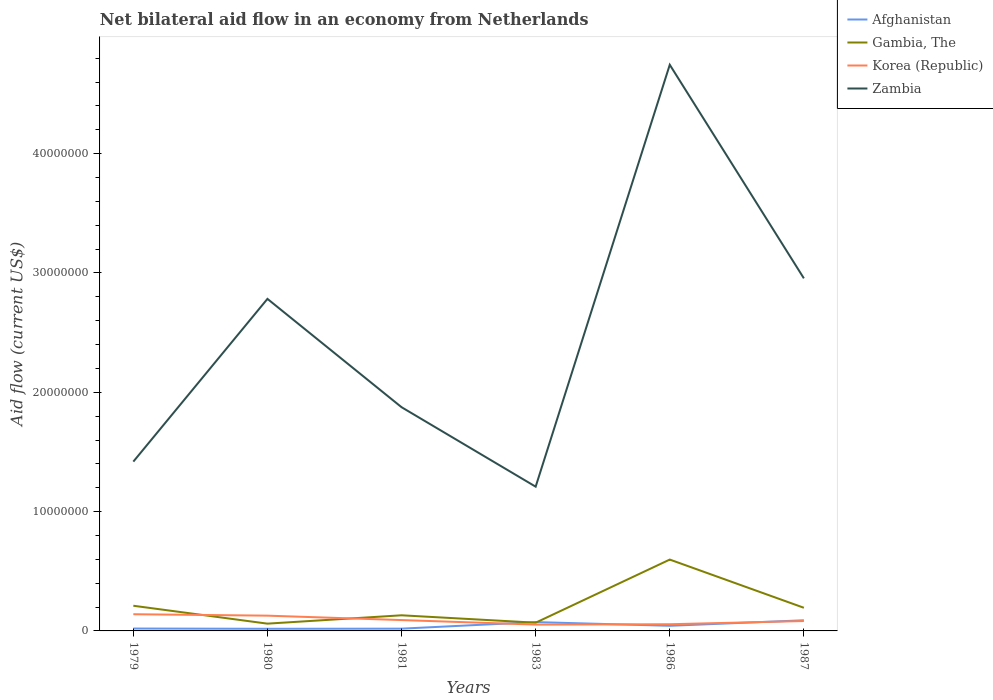Does the line corresponding to Korea (Republic) intersect with the line corresponding to Zambia?
Offer a terse response. No. Across all years, what is the maximum net bilateral aid flow in Korea (Republic)?
Provide a succinct answer. 5.30e+05. What is the total net bilateral aid flow in Gambia, The in the graph?
Make the answer very short. -4.67e+06. What is the difference between the highest and the second highest net bilateral aid flow in Gambia, The?
Your answer should be very brief. 5.37e+06. What is the difference between the highest and the lowest net bilateral aid flow in Gambia, The?
Provide a succinct answer. 2. What is the difference between two consecutive major ticks on the Y-axis?
Offer a very short reply. 1.00e+07. Are the values on the major ticks of Y-axis written in scientific E-notation?
Provide a succinct answer. No. Does the graph contain any zero values?
Give a very brief answer. No. Does the graph contain grids?
Offer a terse response. No. What is the title of the graph?
Make the answer very short. Net bilateral aid flow in an economy from Netherlands. What is the label or title of the Y-axis?
Keep it short and to the point. Aid flow (current US$). What is the Aid flow (current US$) in Afghanistan in 1979?
Provide a succinct answer. 2.00e+05. What is the Aid flow (current US$) in Gambia, The in 1979?
Your answer should be compact. 2.11e+06. What is the Aid flow (current US$) of Korea (Republic) in 1979?
Keep it short and to the point. 1.40e+06. What is the Aid flow (current US$) in Zambia in 1979?
Your answer should be very brief. 1.42e+07. What is the Aid flow (current US$) in Gambia, The in 1980?
Provide a short and direct response. 6.10e+05. What is the Aid flow (current US$) of Korea (Republic) in 1980?
Provide a succinct answer. 1.28e+06. What is the Aid flow (current US$) of Zambia in 1980?
Provide a short and direct response. 2.78e+07. What is the Aid flow (current US$) in Afghanistan in 1981?
Give a very brief answer. 1.90e+05. What is the Aid flow (current US$) in Gambia, The in 1981?
Offer a very short reply. 1.31e+06. What is the Aid flow (current US$) in Korea (Republic) in 1981?
Your answer should be very brief. 9.10e+05. What is the Aid flow (current US$) in Zambia in 1981?
Your answer should be compact. 1.88e+07. What is the Aid flow (current US$) in Afghanistan in 1983?
Provide a succinct answer. 7.40e+05. What is the Aid flow (current US$) of Gambia, The in 1983?
Offer a very short reply. 6.90e+05. What is the Aid flow (current US$) in Korea (Republic) in 1983?
Provide a succinct answer. 5.30e+05. What is the Aid flow (current US$) in Zambia in 1983?
Offer a very short reply. 1.21e+07. What is the Aid flow (current US$) in Afghanistan in 1986?
Keep it short and to the point. 4.30e+05. What is the Aid flow (current US$) of Gambia, The in 1986?
Provide a succinct answer. 5.98e+06. What is the Aid flow (current US$) in Korea (Republic) in 1986?
Provide a short and direct response. 5.60e+05. What is the Aid flow (current US$) of Zambia in 1986?
Make the answer very short. 4.74e+07. What is the Aid flow (current US$) of Afghanistan in 1987?
Provide a succinct answer. 8.90e+05. What is the Aid flow (current US$) of Gambia, The in 1987?
Give a very brief answer. 1.94e+06. What is the Aid flow (current US$) in Korea (Republic) in 1987?
Give a very brief answer. 8.30e+05. What is the Aid flow (current US$) of Zambia in 1987?
Keep it short and to the point. 2.96e+07. Across all years, what is the maximum Aid flow (current US$) of Afghanistan?
Ensure brevity in your answer.  8.90e+05. Across all years, what is the maximum Aid flow (current US$) of Gambia, The?
Provide a short and direct response. 5.98e+06. Across all years, what is the maximum Aid flow (current US$) in Korea (Republic)?
Ensure brevity in your answer.  1.40e+06. Across all years, what is the maximum Aid flow (current US$) of Zambia?
Ensure brevity in your answer.  4.74e+07. Across all years, what is the minimum Aid flow (current US$) in Afghanistan?
Give a very brief answer. 1.80e+05. Across all years, what is the minimum Aid flow (current US$) in Gambia, The?
Provide a short and direct response. 6.10e+05. Across all years, what is the minimum Aid flow (current US$) in Korea (Republic)?
Give a very brief answer. 5.30e+05. Across all years, what is the minimum Aid flow (current US$) of Zambia?
Make the answer very short. 1.21e+07. What is the total Aid flow (current US$) in Afghanistan in the graph?
Make the answer very short. 2.63e+06. What is the total Aid flow (current US$) in Gambia, The in the graph?
Your answer should be compact. 1.26e+07. What is the total Aid flow (current US$) in Korea (Republic) in the graph?
Ensure brevity in your answer.  5.51e+06. What is the total Aid flow (current US$) of Zambia in the graph?
Provide a short and direct response. 1.50e+08. What is the difference between the Aid flow (current US$) of Afghanistan in 1979 and that in 1980?
Offer a very short reply. 2.00e+04. What is the difference between the Aid flow (current US$) in Gambia, The in 1979 and that in 1980?
Offer a terse response. 1.50e+06. What is the difference between the Aid flow (current US$) of Zambia in 1979 and that in 1980?
Offer a terse response. -1.36e+07. What is the difference between the Aid flow (current US$) of Korea (Republic) in 1979 and that in 1981?
Provide a succinct answer. 4.90e+05. What is the difference between the Aid flow (current US$) of Zambia in 1979 and that in 1981?
Ensure brevity in your answer.  -4.56e+06. What is the difference between the Aid flow (current US$) of Afghanistan in 1979 and that in 1983?
Provide a short and direct response. -5.40e+05. What is the difference between the Aid flow (current US$) in Gambia, The in 1979 and that in 1983?
Offer a terse response. 1.42e+06. What is the difference between the Aid flow (current US$) of Korea (Republic) in 1979 and that in 1983?
Keep it short and to the point. 8.70e+05. What is the difference between the Aid flow (current US$) in Zambia in 1979 and that in 1983?
Offer a terse response. 2.10e+06. What is the difference between the Aid flow (current US$) in Gambia, The in 1979 and that in 1986?
Your response must be concise. -3.87e+06. What is the difference between the Aid flow (current US$) of Korea (Republic) in 1979 and that in 1986?
Provide a short and direct response. 8.40e+05. What is the difference between the Aid flow (current US$) in Zambia in 1979 and that in 1986?
Keep it short and to the point. -3.33e+07. What is the difference between the Aid flow (current US$) of Afghanistan in 1979 and that in 1987?
Offer a terse response. -6.90e+05. What is the difference between the Aid flow (current US$) in Gambia, The in 1979 and that in 1987?
Provide a short and direct response. 1.70e+05. What is the difference between the Aid flow (current US$) of Korea (Republic) in 1979 and that in 1987?
Provide a succinct answer. 5.70e+05. What is the difference between the Aid flow (current US$) in Zambia in 1979 and that in 1987?
Your response must be concise. -1.54e+07. What is the difference between the Aid flow (current US$) in Afghanistan in 1980 and that in 1981?
Keep it short and to the point. -10000. What is the difference between the Aid flow (current US$) of Gambia, The in 1980 and that in 1981?
Ensure brevity in your answer.  -7.00e+05. What is the difference between the Aid flow (current US$) of Korea (Republic) in 1980 and that in 1981?
Your answer should be compact. 3.70e+05. What is the difference between the Aid flow (current US$) of Zambia in 1980 and that in 1981?
Make the answer very short. 9.08e+06. What is the difference between the Aid flow (current US$) in Afghanistan in 1980 and that in 1983?
Offer a terse response. -5.60e+05. What is the difference between the Aid flow (current US$) of Korea (Republic) in 1980 and that in 1983?
Your answer should be very brief. 7.50e+05. What is the difference between the Aid flow (current US$) in Zambia in 1980 and that in 1983?
Your response must be concise. 1.57e+07. What is the difference between the Aid flow (current US$) of Afghanistan in 1980 and that in 1986?
Offer a very short reply. -2.50e+05. What is the difference between the Aid flow (current US$) of Gambia, The in 1980 and that in 1986?
Your response must be concise. -5.37e+06. What is the difference between the Aid flow (current US$) of Korea (Republic) in 1980 and that in 1986?
Provide a short and direct response. 7.20e+05. What is the difference between the Aid flow (current US$) in Zambia in 1980 and that in 1986?
Make the answer very short. -1.96e+07. What is the difference between the Aid flow (current US$) of Afghanistan in 1980 and that in 1987?
Ensure brevity in your answer.  -7.10e+05. What is the difference between the Aid flow (current US$) of Gambia, The in 1980 and that in 1987?
Your response must be concise. -1.33e+06. What is the difference between the Aid flow (current US$) in Zambia in 1980 and that in 1987?
Give a very brief answer. -1.72e+06. What is the difference between the Aid flow (current US$) in Afghanistan in 1981 and that in 1983?
Ensure brevity in your answer.  -5.50e+05. What is the difference between the Aid flow (current US$) of Gambia, The in 1981 and that in 1983?
Offer a very short reply. 6.20e+05. What is the difference between the Aid flow (current US$) in Zambia in 1981 and that in 1983?
Provide a succinct answer. 6.66e+06. What is the difference between the Aid flow (current US$) of Afghanistan in 1981 and that in 1986?
Provide a succinct answer. -2.40e+05. What is the difference between the Aid flow (current US$) in Gambia, The in 1981 and that in 1986?
Your answer should be very brief. -4.67e+06. What is the difference between the Aid flow (current US$) of Korea (Republic) in 1981 and that in 1986?
Your response must be concise. 3.50e+05. What is the difference between the Aid flow (current US$) in Zambia in 1981 and that in 1986?
Offer a terse response. -2.87e+07. What is the difference between the Aid flow (current US$) of Afghanistan in 1981 and that in 1987?
Your answer should be compact. -7.00e+05. What is the difference between the Aid flow (current US$) in Gambia, The in 1981 and that in 1987?
Ensure brevity in your answer.  -6.30e+05. What is the difference between the Aid flow (current US$) of Korea (Republic) in 1981 and that in 1987?
Your response must be concise. 8.00e+04. What is the difference between the Aid flow (current US$) of Zambia in 1981 and that in 1987?
Provide a short and direct response. -1.08e+07. What is the difference between the Aid flow (current US$) of Afghanistan in 1983 and that in 1986?
Keep it short and to the point. 3.10e+05. What is the difference between the Aid flow (current US$) of Gambia, The in 1983 and that in 1986?
Offer a very short reply. -5.29e+06. What is the difference between the Aid flow (current US$) of Korea (Republic) in 1983 and that in 1986?
Make the answer very short. -3.00e+04. What is the difference between the Aid flow (current US$) of Zambia in 1983 and that in 1986?
Provide a succinct answer. -3.54e+07. What is the difference between the Aid flow (current US$) of Afghanistan in 1983 and that in 1987?
Your answer should be compact. -1.50e+05. What is the difference between the Aid flow (current US$) of Gambia, The in 1983 and that in 1987?
Your response must be concise. -1.25e+06. What is the difference between the Aid flow (current US$) of Korea (Republic) in 1983 and that in 1987?
Ensure brevity in your answer.  -3.00e+05. What is the difference between the Aid flow (current US$) in Zambia in 1983 and that in 1987?
Your answer should be very brief. -1.75e+07. What is the difference between the Aid flow (current US$) in Afghanistan in 1986 and that in 1987?
Give a very brief answer. -4.60e+05. What is the difference between the Aid flow (current US$) in Gambia, The in 1986 and that in 1987?
Your answer should be compact. 4.04e+06. What is the difference between the Aid flow (current US$) in Zambia in 1986 and that in 1987?
Offer a very short reply. 1.79e+07. What is the difference between the Aid flow (current US$) in Afghanistan in 1979 and the Aid flow (current US$) in Gambia, The in 1980?
Make the answer very short. -4.10e+05. What is the difference between the Aid flow (current US$) in Afghanistan in 1979 and the Aid flow (current US$) in Korea (Republic) in 1980?
Offer a terse response. -1.08e+06. What is the difference between the Aid flow (current US$) in Afghanistan in 1979 and the Aid flow (current US$) in Zambia in 1980?
Give a very brief answer. -2.76e+07. What is the difference between the Aid flow (current US$) in Gambia, The in 1979 and the Aid flow (current US$) in Korea (Republic) in 1980?
Make the answer very short. 8.30e+05. What is the difference between the Aid flow (current US$) of Gambia, The in 1979 and the Aid flow (current US$) of Zambia in 1980?
Your answer should be very brief. -2.57e+07. What is the difference between the Aid flow (current US$) in Korea (Republic) in 1979 and the Aid flow (current US$) in Zambia in 1980?
Your response must be concise. -2.64e+07. What is the difference between the Aid flow (current US$) in Afghanistan in 1979 and the Aid flow (current US$) in Gambia, The in 1981?
Make the answer very short. -1.11e+06. What is the difference between the Aid flow (current US$) of Afghanistan in 1979 and the Aid flow (current US$) of Korea (Republic) in 1981?
Your response must be concise. -7.10e+05. What is the difference between the Aid flow (current US$) of Afghanistan in 1979 and the Aid flow (current US$) of Zambia in 1981?
Offer a terse response. -1.86e+07. What is the difference between the Aid flow (current US$) of Gambia, The in 1979 and the Aid flow (current US$) of Korea (Republic) in 1981?
Offer a terse response. 1.20e+06. What is the difference between the Aid flow (current US$) in Gambia, The in 1979 and the Aid flow (current US$) in Zambia in 1981?
Provide a short and direct response. -1.66e+07. What is the difference between the Aid flow (current US$) in Korea (Republic) in 1979 and the Aid flow (current US$) in Zambia in 1981?
Keep it short and to the point. -1.74e+07. What is the difference between the Aid flow (current US$) of Afghanistan in 1979 and the Aid flow (current US$) of Gambia, The in 1983?
Provide a short and direct response. -4.90e+05. What is the difference between the Aid flow (current US$) of Afghanistan in 1979 and the Aid flow (current US$) of Korea (Republic) in 1983?
Make the answer very short. -3.30e+05. What is the difference between the Aid flow (current US$) of Afghanistan in 1979 and the Aid flow (current US$) of Zambia in 1983?
Keep it short and to the point. -1.19e+07. What is the difference between the Aid flow (current US$) in Gambia, The in 1979 and the Aid flow (current US$) in Korea (Republic) in 1983?
Make the answer very short. 1.58e+06. What is the difference between the Aid flow (current US$) of Gambia, The in 1979 and the Aid flow (current US$) of Zambia in 1983?
Keep it short and to the point. -9.98e+06. What is the difference between the Aid flow (current US$) in Korea (Republic) in 1979 and the Aid flow (current US$) in Zambia in 1983?
Make the answer very short. -1.07e+07. What is the difference between the Aid flow (current US$) of Afghanistan in 1979 and the Aid flow (current US$) of Gambia, The in 1986?
Offer a terse response. -5.78e+06. What is the difference between the Aid flow (current US$) of Afghanistan in 1979 and the Aid flow (current US$) of Korea (Republic) in 1986?
Keep it short and to the point. -3.60e+05. What is the difference between the Aid flow (current US$) of Afghanistan in 1979 and the Aid flow (current US$) of Zambia in 1986?
Offer a very short reply. -4.72e+07. What is the difference between the Aid flow (current US$) of Gambia, The in 1979 and the Aid flow (current US$) of Korea (Republic) in 1986?
Keep it short and to the point. 1.55e+06. What is the difference between the Aid flow (current US$) in Gambia, The in 1979 and the Aid flow (current US$) in Zambia in 1986?
Ensure brevity in your answer.  -4.53e+07. What is the difference between the Aid flow (current US$) in Korea (Republic) in 1979 and the Aid flow (current US$) in Zambia in 1986?
Your answer should be compact. -4.60e+07. What is the difference between the Aid flow (current US$) of Afghanistan in 1979 and the Aid flow (current US$) of Gambia, The in 1987?
Keep it short and to the point. -1.74e+06. What is the difference between the Aid flow (current US$) in Afghanistan in 1979 and the Aid flow (current US$) in Korea (Republic) in 1987?
Offer a terse response. -6.30e+05. What is the difference between the Aid flow (current US$) in Afghanistan in 1979 and the Aid flow (current US$) in Zambia in 1987?
Keep it short and to the point. -2.94e+07. What is the difference between the Aid flow (current US$) in Gambia, The in 1979 and the Aid flow (current US$) in Korea (Republic) in 1987?
Ensure brevity in your answer.  1.28e+06. What is the difference between the Aid flow (current US$) of Gambia, The in 1979 and the Aid flow (current US$) of Zambia in 1987?
Your answer should be very brief. -2.74e+07. What is the difference between the Aid flow (current US$) of Korea (Republic) in 1979 and the Aid flow (current US$) of Zambia in 1987?
Your answer should be very brief. -2.82e+07. What is the difference between the Aid flow (current US$) in Afghanistan in 1980 and the Aid flow (current US$) in Gambia, The in 1981?
Give a very brief answer. -1.13e+06. What is the difference between the Aid flow (current US$) in Afghanistan in 1980 and the Aid flow (current US$) in Korea (Republic) in 1981?
Give a very brief answer. -7.30e+05. What is the difference between the Aid flow (current US$) of Afghanistan in 1980 and the Aid flow (current US$) of Zambia in 1981?
Make the answer very short. -1.86e+07. What is the difference between the Aid flow (current US$) in Gambia, The in 1980 and the Aid flow (current US$) in Zambia in 1981?
Ensure brevity in your answer.  -1.81e+07. What is the difference between the Aid flow (current US$) in Korea (Republic) in 1980 and the Aid flow (current US$) in Zambia in 1981?
Make the answer very short. -1.75e+07. What is the difference between the Aid flow (current US$) in Afghanistan in 1980 and the Aid flow (current US$) in Gambia, The in 1983?
Offer a terse response. -5.10e+05. What is the difference between the Aid flow (current US$) in Afghanistan in 1980 and the Aid flow (current US$) in Korea (Republic) in 1983?
Offer a terse response. -3.50e+05. What is the difference between the Aid flow (current US$) of Afghanistan in 1980 and the Aid flow (current US$) of Zambia in 1983?
Ensure brevity in your answer.  -1.19e+07. What is the difference between the Aid flow (current US$) in Gambia, The in 1980 and the Aid flow (current US$) in Zambia in 1983?
Your answer should be very brief. -1.15e+07. What is the difference between the Aid flow (current US$) of Korea (Republic) in 1980 and the Aid flow (current US$) of Zambia in 1983?
Keep it short and to the point. -1.08e+07. What is the difference between the Aid flow (current US$) of Afghanistan in 1980 and the Aid flow (current US$) of Gambia, The in 1986?
Your response must be concise. -5.80e+06. What is the difference between the Aid flow (current US$) in Afghanistan in 1980 and the Aid flow (current US$) in Korea (Republic) in 1986?
Offer a very short reply. -3.80e+05. What is the difference between the Aid flow (current US$) in Afghanistan in 1980 and the Aid flow (current US$) in Zambia in 1986?
Keep it short and to the point. -4.73e+07. What is the difference between the Aid flow (current US$) of Gambia, The in 1980 and the Aid flow (current US$) of Zambia in 1986?
Make the answer very short. -4.68e+07. What is the difference between the Aid flow (current US$) of Korea (Republic) in 1980 and the Aid flow (current US$) of Zambia in 1986?
Your answer should be very brief. -4.62e+07. What is the difference between the Aid flow (current US$) in Afghanistan in 1980 and the Aid flow (current US$) in Gambia, The in 1987?
Your response must be concise. -1.76e+06. What is the difference between the Aid flow (current US$) in Afghanistan in 1980 and the Aid flow (current US$) in Korea (Republic) in 1987?
Your answer should be compact. -6.50e+05. What is the difference between the Aid flow (current US$) in Afghanistan in 1980 and the Aid flow (current US$) in Zambia in 1987?
Keep it short and to the point. -2.94e+07. What is the difference between the Aid flow (current US$) of Gambia, The in 1980 and the Aid flow (current US$) of Zambia in 1987?
Offer a terse response. -2.89e+07. What is the difference between the Aid flow (current US$) of Korea (Republic) in 1980 and the Aid flow (current US$) of Zambia in 1987?
Provide a succinct answer. -2.83e+07. What is the difference between the Aid flow (current US$) in Afghanistan in 1981 and the Aid flow (current US$) in Gambia, The in 1983?
Keep it short and to the point. -5.00e+05. What is the difference between the Aid flow (current US$) of Afghanistan in 1981 and the Aid flow (current US$) of Zambia in 1983?
Your response must be concise. -1.19e+07. What is the difference between the Aid flow (current US$) in Gambia, The in 1981 and the Aid flow (current US$) in Korea (Republic) in 1983?
Provide a short and direct response. 7.80e+05. What is the difference between the Aid flow (current US$) in Gambia, The in 1981 and the Aid flow (current US$) in Zambia in 1983?
Give a very brief answer. -1.08e+07. What is the difference between the Aid flow (current US$) of Korea (Republic) in 1981 and the Aid flow (current US$) of Zambia in 1983?
Your response must be concise. -1.12e+07. What is the difference between the Aid flow (current US$) in Afghanistan in 1981 and the Aid flow (current US$) in Gambia, The in 1986?
Your response must be concise. -5.79e+06. What is the difference between the Aid flow (current US$) of Afghanistan in 1981 and the Aid flow (current US$) of Korea (Republic) in 1986?
Offer a terse response. -3.70e+05. What is the difference between the Aid flow (current US$) in Afghanistan in 1981 and the Aid flow (current US$) in Zambia in 1986?
Keep it short and to the point. -4.73e+07. What is the difference between the Aid flow (current US$) in Gambia, The in 1981 and the Aid flow (current US$) in Korea (Republic) in 1986?
Provide a succinct answer. 7.50e+05. What is the difference between the Aid flow (current US$) of Gambia, The in 1981 and the Aid flow (current US$) of Zambia in 1986?
Your answer should be very brief. -4.61e+07. What is the difference between the Aid flow (current US$) in Korea (Republic) in 1981 and the Aid flow (current US$) in Zambia in 1986?
Ensure brevity in your answer.  -4.65e+07. What is the difference between the Aid flow (current US$) of Afghanistan in 1981 and the Aid flow (current US$) of Gambia, The in 1987?
Your response must be concise. -1.75e+06. What is the difference between the Aid flow (current US$) of Afghanistan in 1981 and the Aid flow (current US$) of Korea (Republic) in 1987?
Your answer should be very brief. -6.40e+05. What is the difference between the Aid flow (current US$) of Afghanistan in 1981 and the Aid flow (current US$) of Zambia in 1987?
Your answer should be compact. -2.94e+07. What is the difference between the Aid flow (current US$) of Gambia, The in 1981 and the Aid flow (current US$) of Zambia in 1987?
Make the answer very short. -2.82e+07. What is the difference between the Aid flow (current US$) in Korea (Republic) in 1981 and the Aid flow (current US$) in Zambia in 1987?
Your answer should be very brief. -2.86e+07. What is the difference between the Aid flow (current US$) in Afghanistan in 1983 and the Aid flow (current US$) in Gambia, The in 1986?
Give a very brief answer. -5.24e+06. What is the difference between the Aid flow (current US$) of Afghanistan in 1983 and the Aid flow (current US$) of Korea (Republic) in 1986?
Offer a terse response. 1.80e+05. What is the difference between the Aid flow (current US$) of Afghanistan in 1983 and the Aid flow (current US$) of Zambia in 1986?
Keep it short and to the point. -4.67e+07. What is the difference between the Aid flow (current US$) of Gambia, The in 1983 and the Aid flow (current US$) of Korea (Republic) in 1986?
Ensure brevity in your answer.  1.30e+05. What is the difference between the Aid flow (current US$) of Gambia, The in 1983 and the Aid flow (current US$) of Zambia in 1986?
Provide a succinct answer. -4.68e+07. What is the difference between the Aid flow (current US$) in Korea (Republic) in 1983 and the Aid flow (current US$) in Zambia in 1986?
Your answer should be compact. -4.69e+07. What is the difference between the Aid flow (current US$) in Afghanistan in 1983 and the Aid flow (current US$) in Gambia, The in 1987?
Make the answer very short. -1.20e+06. What is the difference between the Aid flow (current US$) in Afghanistan in 1983 and the Aid flow (current US$) in Korea (Republic) in 1987?
Make the answer very short. -9.00e+04. What is the difference between the Aid flow (current US$) of Afghanistan in 1983 and the Aid flow (current US$) of Zambia in 1987?
Offer a very short reply. -2.88e+07. What is the difference between the Aid flow (current US$) of Gambia, The in 1983 and the Aid flow (current US$) of Korea (Republic) in 1987?
Your answer should be very brief. -1.40e+05. What is the difference between the Aid flow (current US$) in Gambia, The in 1983 and the Aid flow (current US$) in Zambia in 1987?
Ensure brevity in your answer.  -2.89e+07. What is the difference between the Aid flow (current US$) of Korea (Republic) in 1983 and the Aid flow (current US$) of Zambia in 1987?
Your answer should be compact. -2.90e+07. What is the difference between the Aid flow (current US$) in Afghanistan in 1986 and the Aid flow (current US$) in Gambia, The in 1987?
Your answer should be compact. -1.51e+06. What is the difference between the Aid flow (current US$) in Afghanistan in 1986 and the Aid flow (current US$) in Korea (Republic) in 1987?
Offer a very short reply. -4.00e+05. What is the difference between the Aid flow (current US$) of Afghanistan in 1986 and the Aid flow (current US$) of Zambia in 1987?
Ensure brevity in your answer.  -2.91e+07. What is the difference between the Aid flow (current US$) of Gambia, The in 1986 and the Aid flow (current US$) of Korea (Republic) in 1987?
Offer a terse response. 5.15e+06. What is the difference between the Aid flow (current US$) of Gambia, The in 1986 and the Aid flow (current US$) of Zambia in 1987?
Make the answer very short. -2.36e+07. What is the difference between the Aid flow (current US$) in Korea (Republic) in 1986 and the Aid flow (current US$) in Zambia in 1987?
Provide a succinct answer. -2.90e+07. What is the average Aid flow (current US$) in Afghanistan per year?
Your answer should be very brief. 4.38e+05. What is the average Aid flow (current US$) in Gambia, The per year?
Keep it short and to the point. 2.11e+06. What is the average Aid flow (current US$) of Korea (Republic) per year?
Provide a short and direct response. 9.18e+05. What is the average Aid flow (current US$) in Zambia per year?
Offer a very short reply. 2.50e+07. In the year 1979, what is the difference between the Aid flow (current US$) of Afghanistan and Aid flow (current US$) of Gambia, The?
Offer a terse response. -1.91e+06. In the year 1979, what is the difference between the Aid flow (current US$) of Afghanistan and Aid flow (current US$) of Korea (Republic)?
Make the answer very short. -1.20e+06. In the year 1979, what is the difference between the Aid flow (current US$) in Afghanistan and Aid flow (current US$) in Zambia?
Provide a succinct answer. -1.40e+07. In the year 1979, what is the difference between the Aid flow (current US$) in Gambia, The and Aid flow (current US$) in Korea (Republic)?
Provide a succinct answer. 7.10e+05. In the year 1979, what is the difference between the Aid flow (current US$) of Gambia, The and Aid flow (current US$) of Zambia?
Give a very brief answer. -1.21e+07. In the year 1979, what is the difference between the Aid flow (current US$) in Korea (Republic) and Aid flow (current US$) in Zambia?
Keep it short and to the point. -1.28e+07. In the year 1980, what is the difference between the Aid flow (current US$) in Afghanistan and Aid flow (current US$) in Gambia, The?
Offer a terse response. -4.30e+05. In the year 1980, what is the difference between the Aid flow (current US$) of Afghanistan and Aid flow (current US$) of Korea (Republic)?
Ensure brevity in your answer.  -1.10e+06. In the year 1980, what is the difference between the Aid flow (current US$) of Afghanistan and Aid flow (current US$) of Zambia?
Provide a succinct answer. -2.76e+07. In the year 1980, what is the difference between the Aid flow (current US$) of Gambia, The and Aid flow (current US$) of Korea (Republic)?
Your answer should be compact. -6.70e+05. In the year 1980, what is the difference between the Aid flow (current US$) in Gambia, The and Aid flow (current US$) in Zambia?
Offer a terse response. -2.72e+07. In the year 1980, what is the difference between the Aid flow (current US$) of Korea (Republic) and Aid flow (current US$) of Zambia?
Provide a succinct answer. -2.66e+07. In the year 1981, what is the difference between the Aid flow (current US$) in Afghanistan and Aid flow (current US$) in Gambia, The?
Ensure brevity in your answer.  -1.12e+06. In the year 1981, what is the difference between the Aid flow (current US$) in Afghanistan and Aid flow (current US$) in Korea (Republic)?
Offer a terse response. -7.20e+05. In the year 1981, what is the difference between the Aid flow (current US$) in Afghanistan and Aid flow (current US$) in Zambia?
Offer a terse response. -1.86e+07. In the year 1981, what is the difference between the Aid flow (current US$) of Gambia, The and Aid flow (current US$) of Zambia?
Offer a very short reply. -1.74e+07. In the year 1981, what is the difference between the Aid flow (current US$) in Korea (Republic) and Aid flow (current US$) in Zambia?
Your answer should be compact. -1.78e+07. In the year 1983, what is the difference between the Aid flow (current US$) in Afghanistan and Aid flow (current US$) in Gambia, The?
Your response must be concise. 5.00e+04. In the year 1983, what is the difference between the Aid flow (current US$) in Afghanistan and Aid flow (current US$) in Korea (Republic)?
Make the answer very short. 2.10e+05. In the year 1983, what is the difference between the Aid flow (current US$) of Afghanistan and Aid flow (current US$) of Zambia?
Offer a terse response. -1.14e+07. In the year 1983, what is the difference between the Aid flow (current US$) in Gambia, The and Aid flow (current US$) in Korea (Republic)?
Offer a very short reply. 1.60e+05. In the year 1983, what is the difference between the Aid flow (current US$) of Gambia, The and Aid flow (current US$) of Zambia?
Provide a short and direct response. -1.14e+07. In the year 1983, what is the difference between the Aid flow (current US$) in Korea (Republic) and Aid flow (current US$) in Zambia?
Provide a short and direct response. -1.16e+07. In the year 1986, what is the difference between the Aid flow (current US$) of Afghanistan and Aid flow (current US$) of Gambia, The?
Your answer should be compact. -5.55e+06. In the year 1986, what is the difference between the Aid flow (current US$) of Afghanistan and Aid flow (current US$) of Zambia?
Provide a short and direct response. -4.70e+07. In the year 1986, what is the difference between the Aid flow (current US$) in Gambia, The and Aid flow (current US$) in Korea (Republic)?
Your answer should be compact. 5.42e+06. In the year 1986, what is the difference between the Aid flow (current US$) of Gambia, The and Aid flow (current US$) of Zambia?
Keep it short and to the point. -4.15e+07. In the year 1986, what is the difference between the Aid flow (current US$) in Korea (Republic) and Aid flow (current US$) in Zambia?
Make the answer very short. -4.69e+07. In the year 1987, what is the difference between the Aid flow (current US$) of Afghanistan and Aid flow (current US$) of Gambia, The?
Keep it short and to the point. -1.05e+06. In the year 1987, what is the difference between the Aid flow (current US$) of Afghanistan and Aid flow (current US$) of Korea (Republic)?
Offer a terse response. 6.00e+04. In the year 1987, what is the difference between the Aid flow (current US$) of Afghanistan and Aid flow (current US$) of Zambia?
Provide a short and direct response. -2.87e+07. In the year 1987, what is the difference between the Aid flow (current US$) in Gambia, The and Aid flow (current US$) in Korea (Republic)?
Give a very brief answer. 1.11e+06. In the year 1987, what is the difference between the Aid flow (current US$) of Gambia, The and Aid flow (current US$) of Zambia?
Offer a terse response. -2.76e+07. In the year 1987, what is the difference between the Aid flow (current US$) in Korea (Republic) and Aid flow (current US$) in Zambia?
Offer a very short reply. -2.87e+07. What is the ratio of the Aid flow (current US$) in Gambia, The in 1979 to that in 1980?
Provide a succinct answer. 3.46. What is the ratio of the Aid flow (current US$) of Korea (Republic) in 1979 to that in 1980?
Give a very brief answer. 1.09. What is the ratio of the Aid flow (current US$) of Zambia in 1979 to that in 1980?
Make the answer very short. 0.51. What is the ratio of the Aid flow (current US$) in Afghanistan in 1979 to that in 1981?
Offer a very short reply. 1.05. What is the ratio of the Aid flow (current US$) in Gambia, The in 1979 to that in 1981?
Your answer should be compact. 1.61. What is the ratio of the Aid flow (current US$) of Korea (Republic) in 1979 to that in 1981?
Provide a succinct answer. 1.54. What is the ratio of the Aid flow (current US$) of Zambia in 1979 to that in 1981?
Your answer should be very brief. 0.76. What is the ratio of the Aid flow (current US$) of Afghanistan in 1979 to that in 1983?
Provide a short and direct response. 0.27. What is the ratio of the Aid flow (current US$) of Gambia, The in 1979 to that in 1983?
Make the answer very short. 3.06. What is the ratio of the Aid flow (current US$) in Korea (Republic) in 1979 to that in 1983?
Your answer should be very brief. 2.64. What is the ratio of the Aid flow (current US$) of Zambia in 1979 to that in 1983?
Provide a succinct answer. 1.17. What is the ratio of the Aid flow (current US$) in Afghanistan in 1979 to that in 1986?
Make the answer very short. 0.47. What is the ratio of the Aid flow (current US$) of Gambia, The in 1979 to that in 1986?
Provide a succinct answer. 0.35. What is the ratio of the Aid flow (current US$) of Zambia in 1979 to that in 1986?
Ensure brevity in your answer.  0.3. What is the ratio of the Aid flow (current US$) of Afghanistan in 1979 to that in 1987?
Your answer should be very brief. 0.22. What is the ratio of the Aid flow (current US$) in Gambia, The in 1979 to that in 1987?
Your answer should be very brief. 1.09. What is the ratio of the Aid flow (current US$) in Korea (Republic) in 1979 to that in 1987?
Your answer should be very brief. 1.69. What is the ratio of the Aid flow (current US$) in Zambia in 1979 to that in 1987?
Make the answer very short. 0.48. What is the ratio of the Aid flow (current US$) of Afghanistan in 1980 to that in 1981?
Your answer should be compact. 0.95. What is the ratio of the Aid flow (current US$) in Gambia, The in 1980 to that in 1981?
Your answer should be very brief. 0.47. What is the ratio of the Aid flow (current US$) of Korea (Republic) in 1980 to that in 1981?
Provide a short and direct response. 1.41. What is the ratio of the Aid flow (current US$) of Zambia in 1980 to that in 1981?
Provide a succinct answer. 1.48. What is the ratio of the Aid flow (current US$) of Afghanistan in 1980 to that in 1983?
Offer a very short reply. 0.24. What is the ratio of the Aid flow (current US$) in Gambia, The in 1980 to that in 1983?
Your answer should be very brief. 0.88. What is the ratio of the Aid flow (current US$) of Korea (Republic) in 1980 to that in 1983?
Your answer should be compact. 2.42. What is the ratio of the Aid flow (current US$) of Zambia in 1980 to that in 1983?
Keep it short and to the point. 2.3. What is the ratio of the Aid flow (current US$) of Afghanistan in 1980 to that in 1986?
Your answer should be compact. 0.42. What is the ratio of the Aid flow (current US$) in Gambia, The in 1980 to that in 1986?
Provide a succinct answer. 0.1. What is the ratio of the Aid flow (current US$) in Korea (Republic) in 1980 to that in 1986?
Provide a succinct answer. 2.29. What is the ratio of the Aid flow (current US$) of Zambia in 1980 to that in 1986?
Offer a terse response. 0.59. What is the ratio of the Aid flow (current US$) in Afghanistan in 1980 to that in 1987?
Your answer should be compact. 0.2. What is the ratio of the Aid flow (current US$) in Gambia, The in 1980 to that in 1987?
Your answer should be compact. 0.31. What is the ratio of the Aid flow (current US$) in Korea (Republic) in 1980 to that in 1987?
Your answer should be compact. 1.54. What is the ratio of the Aid flow (current US$) in Zambia in 1980 to that in 1987?
Make the answer very short. 0.94. What is the ratio of the Aid flow (current US$) in Afghanistan in 1981 to that in 1983?
Offer a terse response. 0.26. What is the ratio of the Aid flow (current US$) in Gambia, The in 1981 to that in 1983?
Your answer should be very brief. 1.9. What is the ratio of the Aid flow (current US$) of Korea (Republic) in 1981 to that in 1983?
Give a very brief answer. 1.72. What is the ratio of the Aid flow (current US$) in Zambia in 1981 to that in 1983?
Provide a short and direct response. 1.55. What is the ratio of the Aid flow (current US$) in Afghanistan in 1981 to that in 1986?
Give a very brief answer. 0.44. What is the ratio of the Aid flow (current US$) in Gambia, The in 1981 to that in 1986?
Offer a very short reply. 0.22. What is the ratio of the Aid flow (current US$) in Korea (Republic) in 1981 to that in 1986?
Your answer should be very brief. 1.62. What is the ratio of the Aid flow (current US$) in Zambia in 1981 to that in 1986?
Give a very brief answer. 0.4. What is the ratio of the Aid flow (current US$) in Afghanistan in 1981 to that in 1987?
Your answer should be compact. 0.21. What is the ratio of the Aid flow (current US$) in Gambia, The in 1981 to that in 1987?
Offer a terse response. 0.68. What is the ratio of the Aid flow (current US$) in Korea (Republic) in 1981 to that in 1987?
Offer a terse response. 1.1. What is the ratio of the Aid flow (current US$) of Zambia in 1981 to that in 1987?
Give a very brief answer. 0.63. What is the ratio of the Aid flow (current US$) of Afghanistan in 1983 to that in 1986?
Ensure brevity in your answer.  1.72. What is the ratio of the Aid flow (current US$) in Gambia, The in 1983 to that in 1986?
Ensure brevity in your answer.  0.12. What is the ratio of the Aid flow (current US$) of Korea (Republic) in 1983 to that in 1986?
Your answer should be very brief. 0.95. What is the ratio of the Aid flow (current US$) of Zambia in 1983 to that in 1986?
Offer a very short reply. 0.25. What is the ratio of the Aid flow (current US$) of Afghanistan in 1983 to that in 1987?
Your answer should be very brief. 0.83. What is the ratio of the Aid flow (current US$) in Gambia, The in 1983 to that in 1987?
Give a very brief answer. 0.36. What is the ratio of the Aid flow (current US$) in Korea (Republic) in 1983 to that in 1987?
Provide a short and direct response. 0.64. What is the ratio of the Aid flow (current US$) in Zambia in 1983 to that in 1987?
Offer a very short reply. 0.41. What is the ratio of the Aid flow (current US$) of Afghanistan in 1986 to that in 1987?
Provide a succinct answer. 0.48. What is the ratio of the Aid flow (current US$) in Gambia, The in 1986 to that in 1987?
Provide a short and direct response. 3.08. What is the ratio of the Aid flow (current US$) of Korea (Republic) in 1986 to that in 1987?
Provide a short and direct response. 0.67. What is the ratio of the Aid flow (current US$) in Zambia in 1986 to that in 1987?
Your answer should be compact. 1.61. What is the difference between the highest and the second highest Aid flow (current US$) in Afghanistan?
Offer a very short reply. 1.50e+05. What is the difference between the highest and the second highest Aid flow (current US$) of Gambia, The?
Offer a very short reply. 3.87e+06. What is the difference between the highest and the second highest Aid flow (current US$) of Zambia?
Keep it short and to the point. 1.79e+07. What is the difference between the highest and the lowest Aid flow (current US$) in Afghanistan?
Your answer should be very brief. 7.10e+05. What is the difference between the highest and the lowest Aid flow (current US$) in Gambia, The?
Give a very brief answer. 5.37e+06. What is the difference between the highest and the lowest Aid flow (current US$) of Korea (Republic)?
Provide a short and direct response. 8.70e+05. What is the difference between the highest and the lowest Aid flow (current US$) of Zambia?
Provide a short and direct response. 3.54e+07. 